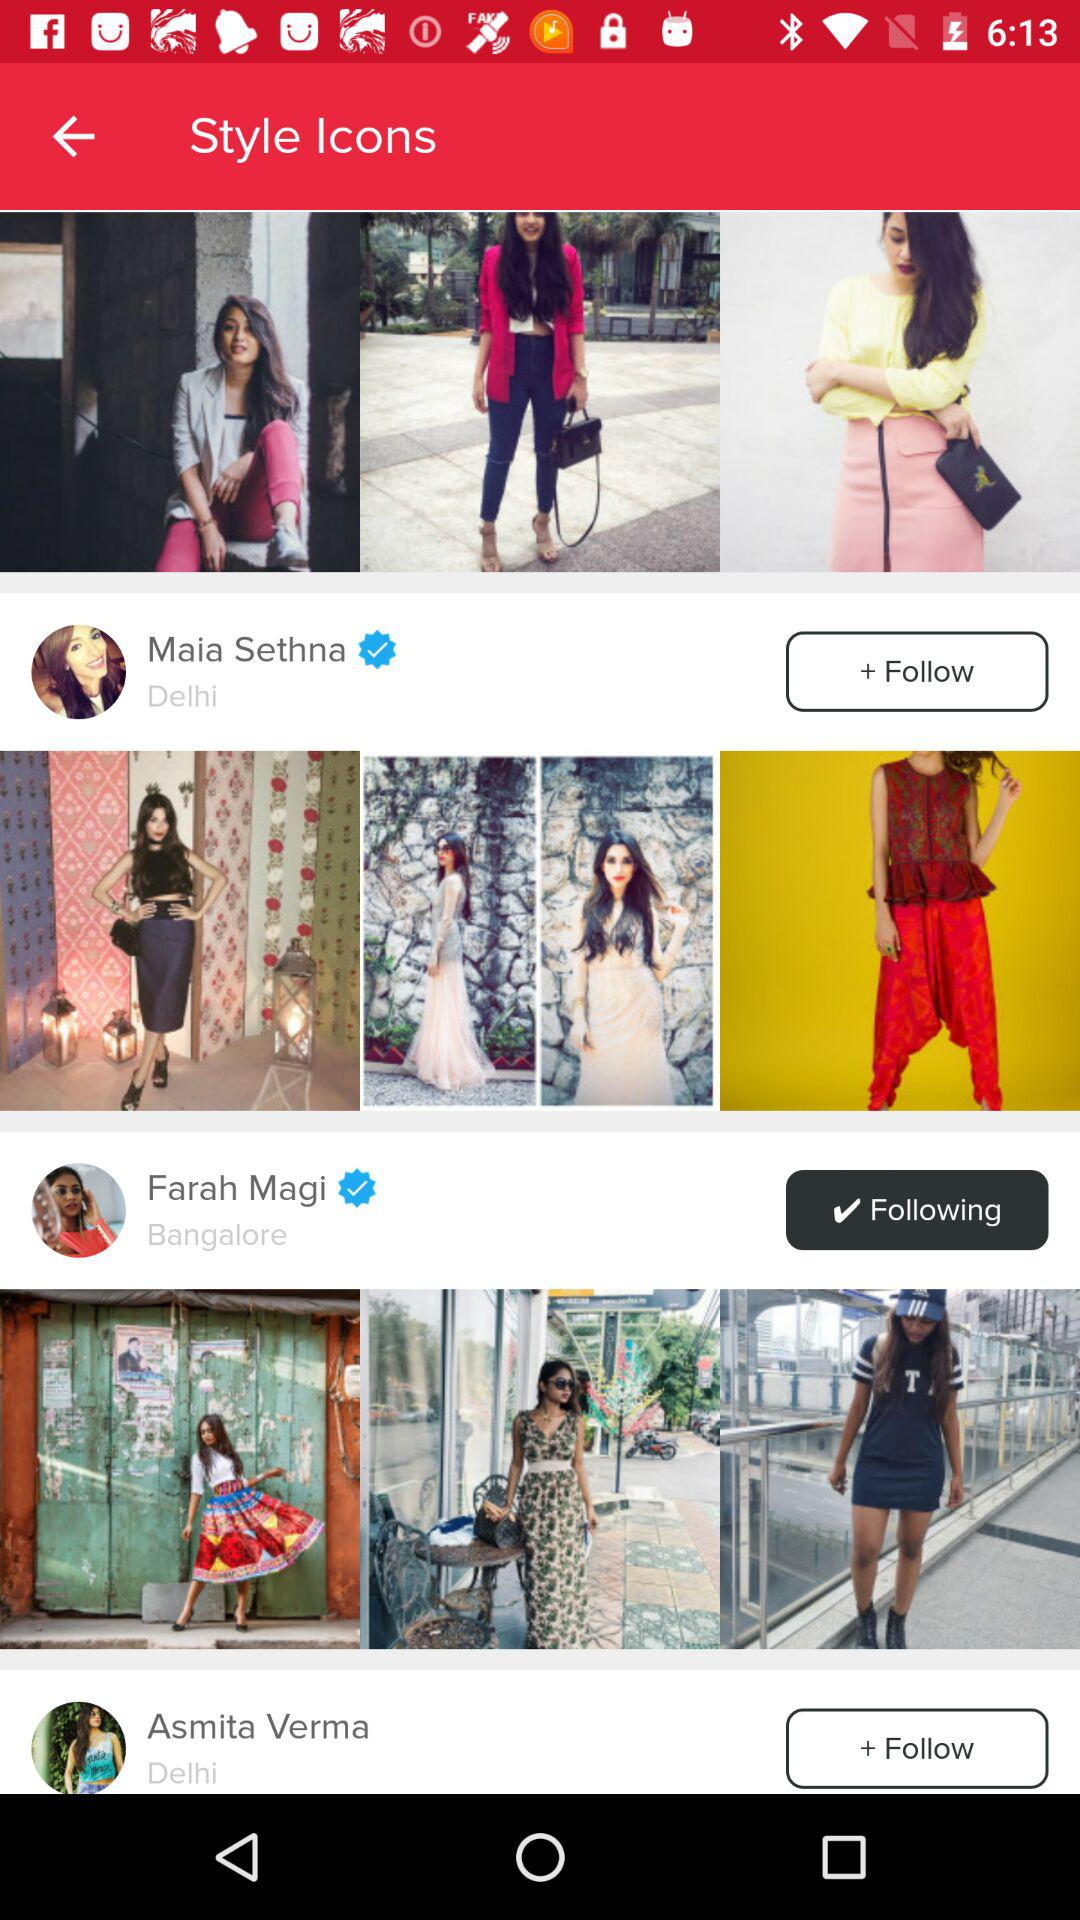Where is Asmita Verma from? Asmita Verma is from Delhi. 